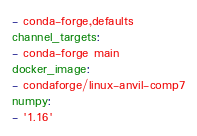<code> <loc_0><loc_0><loc_500><loc_500><_YAML_>- conda-forge,defaults
channel_targets:
- conda-forge main
docker_image:
- condaforge/linux-anvil-comp7
numpy:
- '1.16'
</code> 